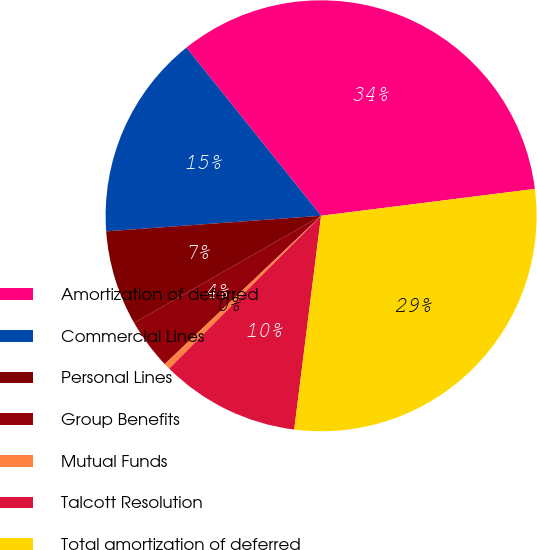Convert chart to OTSL. <chart><loc_0><loc_0><loc_500><loc_500><pie_chart><fcel>Amortization of deferred<fcel>Commercial Lines<fcel>Personal Lines<fcel>Group Benefits<fcel>Mutual Funds<fcel>Talcott Resolution<fcel>Total amortization of deferred<nl><fcel>33.76%<fcel>15.4%<fcel>7.13%<fcel>3.8%<fcel>0.47%<fcel>10.46%<fcel>28.98%<nl></chart> 